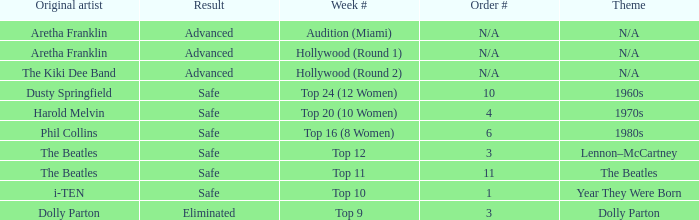What is the order number that has Aretha Franklin as the original artist? N/A, N/A. 